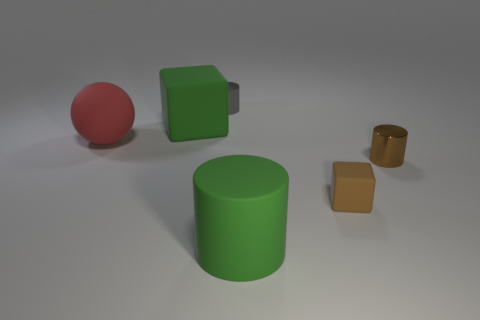What number of other things are there of the same material as the gray thing
Your answer should be very brief. 1. The rubber sphere has what color?
Offer a very short reply. Red. Are there any gray cylinders that are in front of the red rubber ball left of the small brown block?
Offer a terse response. No. Are there fewer rubber cubes to the left of the red object than matte objects?
Your answer should be very brief. Yes. Does the large thing behind the large ball have the same material as the big cylinder?
Keep it short and to the point. Yes. There is another cylinder that is the same material as the brown cylinder; what is its color?
Give a very brief answer. Gray. Is the number of large green objects that are behind the tiny brown matte block less than the number of red matte balls that are behind the large red matte object?
Make the answer very short. No. Is the color of the tiny metal cylinder on the left side of the brown matte thing the same as the thing on the right side of the small cube?
Provide a short and direct response. No. Is there a tiny block made of the same material as the tiny gray cylinder?
Keep it short and to the point. No. What is the size of the metal object that is behind the metallic cylinder that is in front of the gray cylinder?
Ensure brevity in your answer.  Small. 